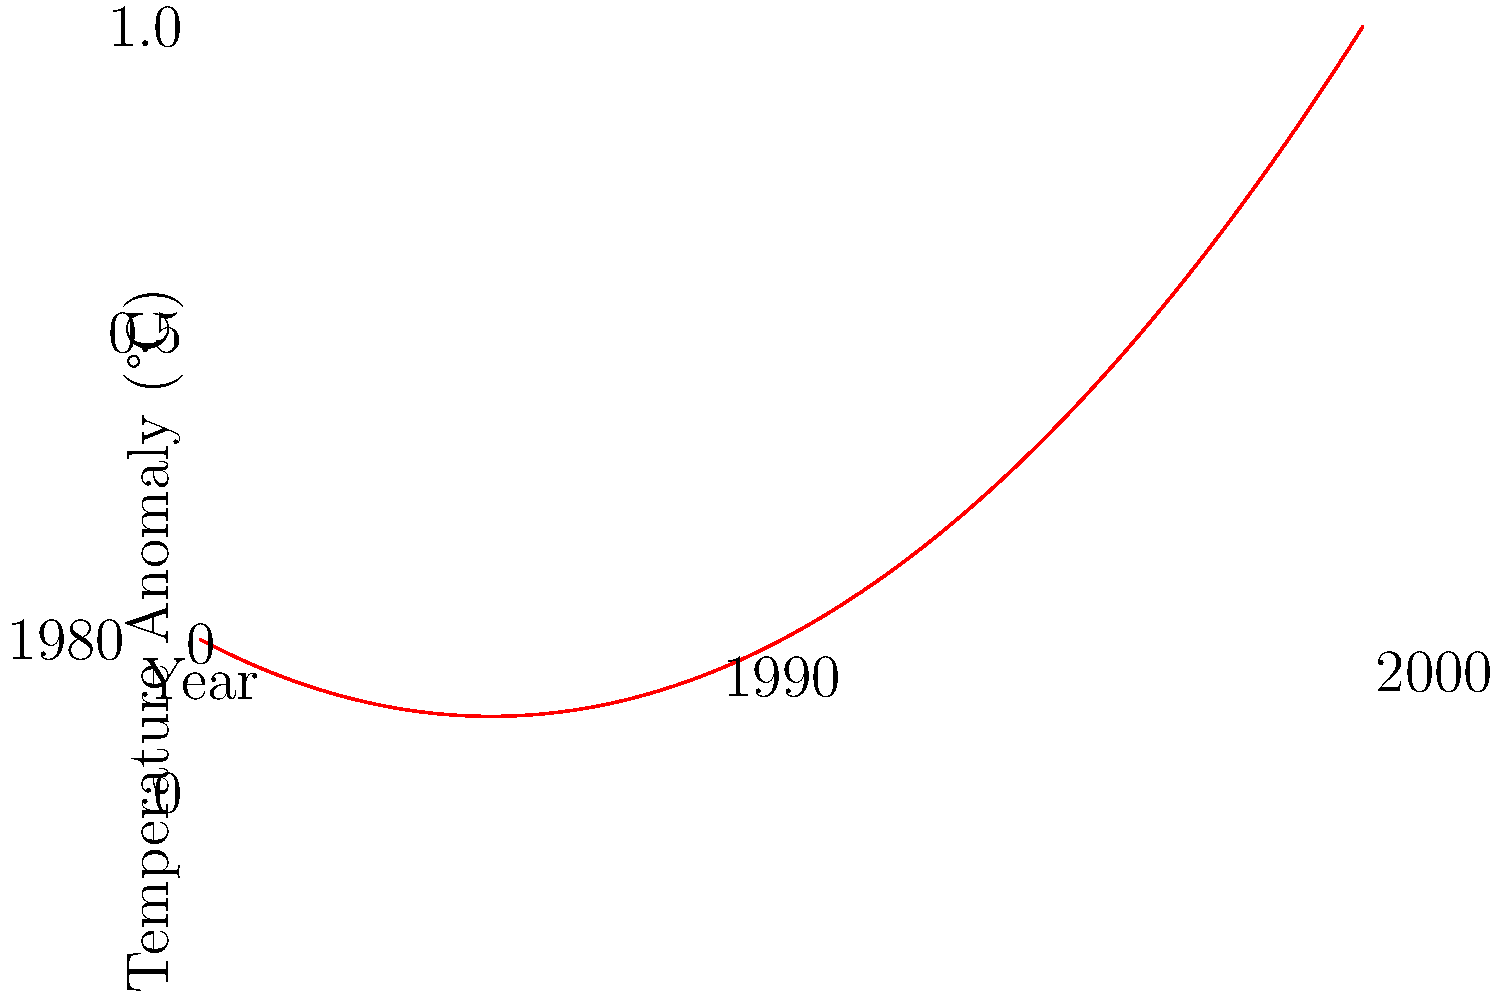Based on the global temperature anomaly trend shown in the graph, what can be inferred about the rate of warming between 1980 and 2000? To interpret the rate of warming from the graph, we need to analyze the slope of the curve:

1. Observe the curve's shape: It's not a straight line but curves upward, indicating acceleration.

2. Compare the beginning and end:
   - In 1980 (left side), the anomaly is close to 0°C.
   - In 2000 (right side), the anomaly is about 1°C.

3. Analyze the slope:
   - The slope is increasing from left to right.
   - This means the rate of temperature change is increasing over time.

4. Interpret the acceleration:
   - The curve's steepness increases more rapidly in the latter part of the period.
   - This suggests the warming rate was higher in the 1990s compared to the 1980s.

5. Scientific context:
   - Accelerating warming is consistent with increased greenhouse gas emissions and positive feedback loops in the climate system.

Therefore, the graph shows that the rate of global warming accelerated between 1980 and 2000, with a more rapid increase in the latter part of this period.
Answer: Accelerating warming rate 